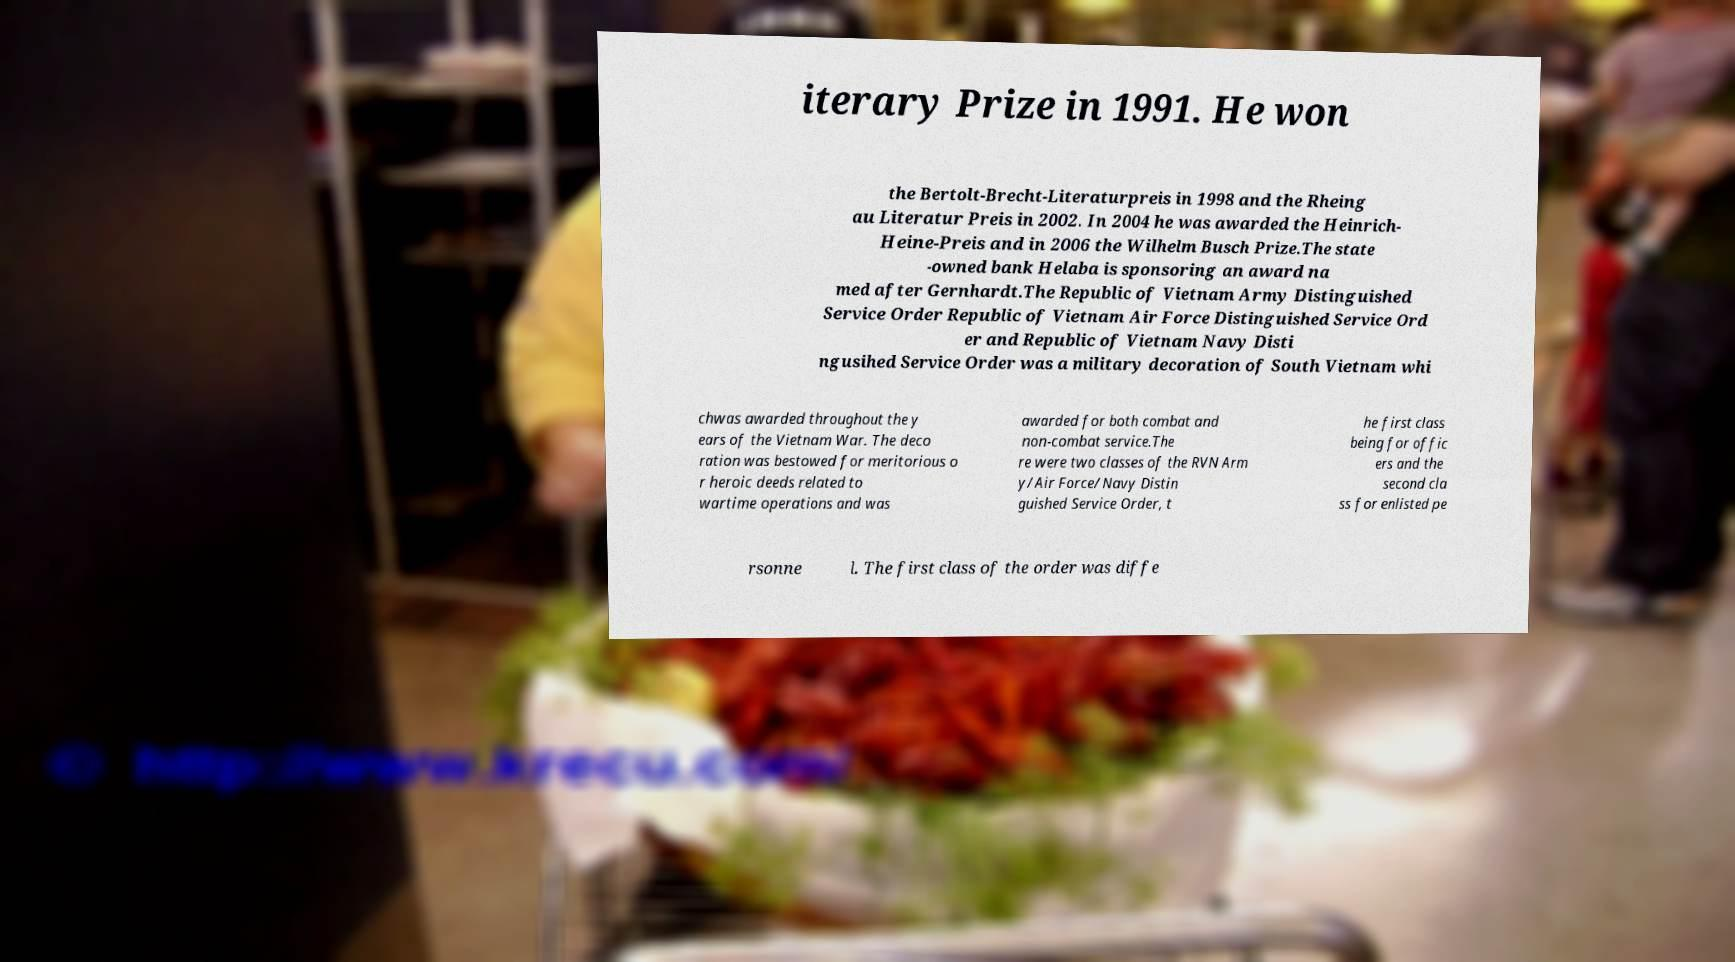Can you read and provide the text displayed in the image?This photo seems to have some interesting text. Can you extract and type it out for me? iterary Prize in 1991. He won the Bertolt-Brecht-Literaturpreis in 1998 and the Rheing au Literatur Preis in 2002. In 2004 he was awarded the Heinrich- Heine-Preis and in 2006 the Wilhelm Busch Prize.The state -owned bank Helaba is sponsoring an award na med after Gernhardt.The Republic of Vietnam Army Distinguished Service Order Republic of Vietnam Air Force Distinguished Service Ord er and Republic of Vietnam Navy Disti ngusihed Service Order was a military decoration of South Vietnam whi chwas awarded throughout the y ears of the Vietnam War. The deco ration was bestowed for meritorious o r heroic deeds related to wartime operations and was awarded for both combat and non-combat service.The re were two classes of the RVN Arm y/Air Force/Navy Distin guished Service Order, t he first class being for offic ers and the second cla ss for enlisted pe rsonne l. The first class of the order was diffe 